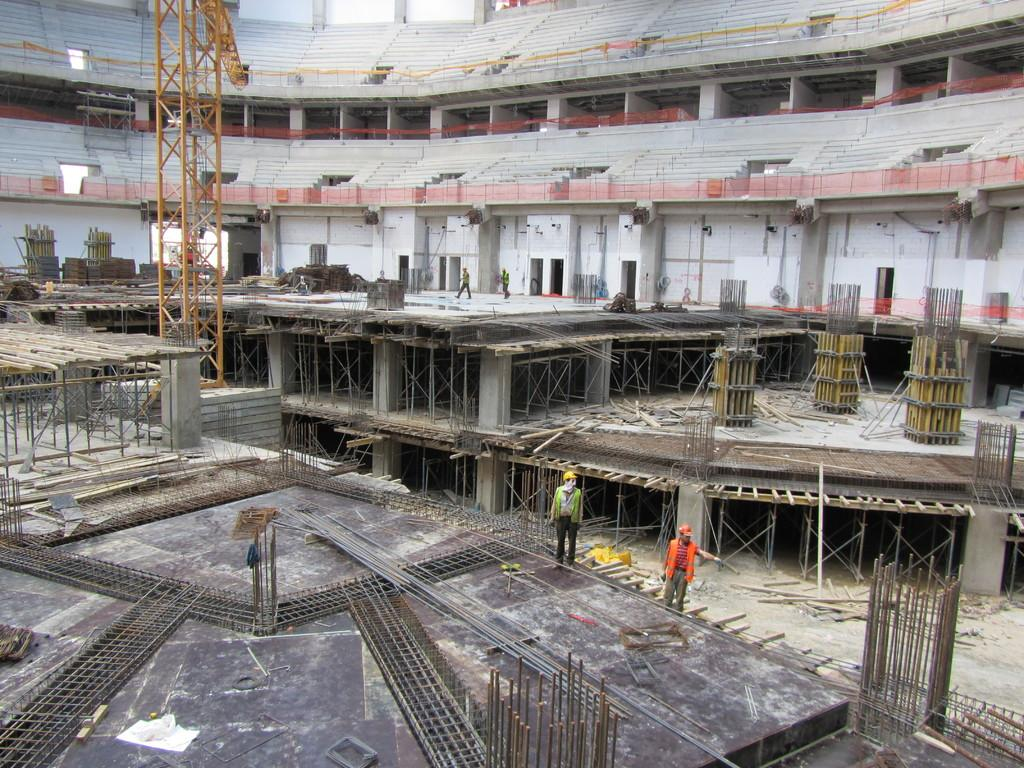What activity is taking place in the image? The image shows the construction of buildings. What materials are visible in the image? There are iron rods, bricks, and pillars in the image. How many people are present in the image? There are two persons standing in the image. What are the persons wearing? The persons are wearing helmets. Can you see a bottle of water being used by the workers in the image? There is no bottle of water visible in the image. What type of lace is being used to decorate the construction site? There is no lace present in the image; it is a construction site with no decorative elements. 